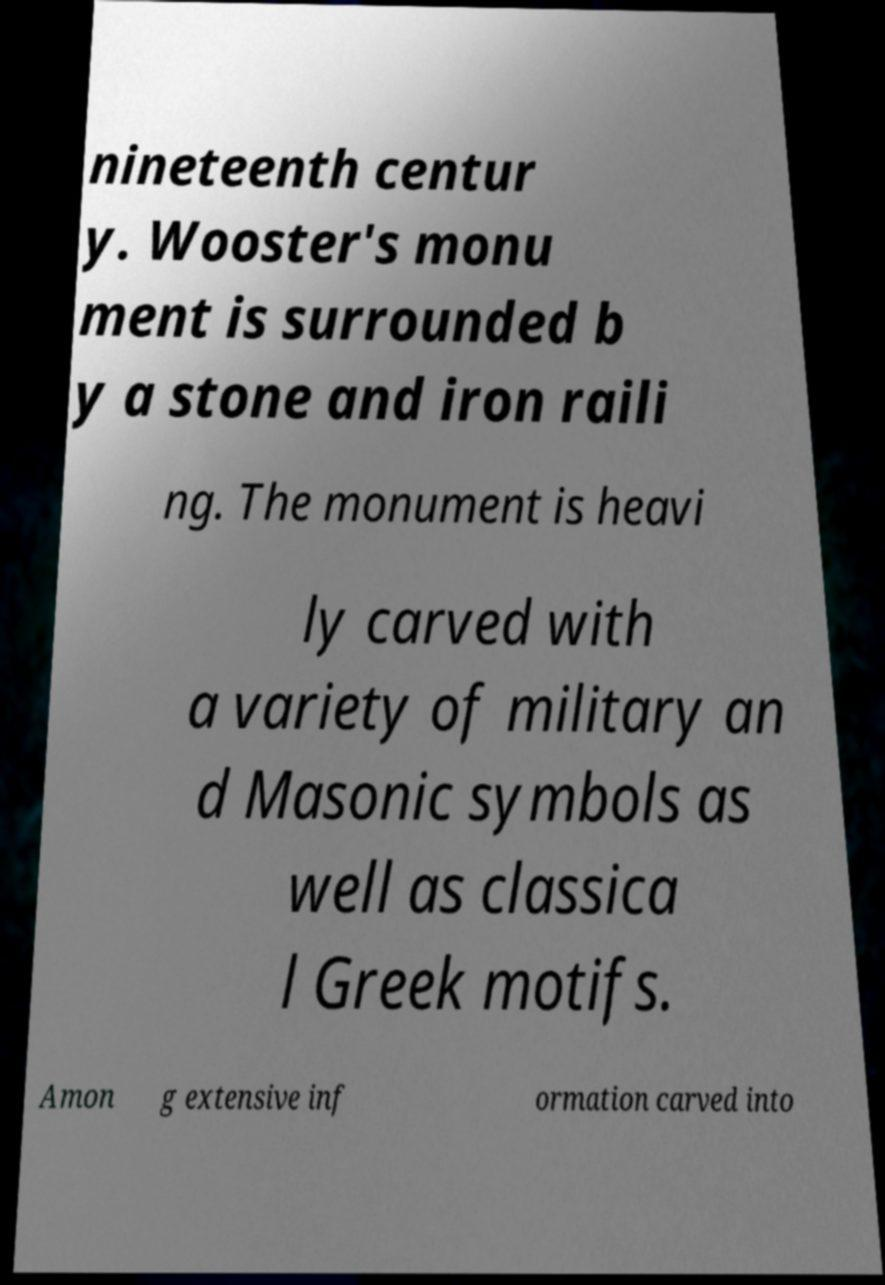Can you read and provide the text displayed in the image?This photo seems to have some interesting text. Can you extract and type it out for me? nineteenth centur y. Wooster's monu ment is surrounded b y a stone and iron raili ng. The monument is heavi ly carved with a variety of military an d Masonic symbols as well as classica l Greek motifs. Amon g extensive inf ormation carved into 